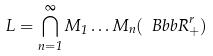<formula> <loc_0><loc_0><loc_500><loc_500>L = \bigcap _ { n = 1 } ^ { \infty } M _ { 1 } \dots M _ { n } ( { \ B b b R } ^ { r } _ { + } )</formula> 